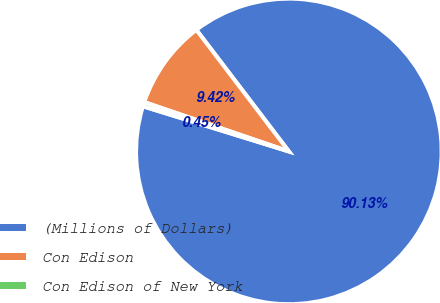<chart> <loc_0><loc_0><loc_500><loc_500><pie_chart><fcel>(Millions of Dollars)<fcel>Con Edison<fcel>Con Edison of New York<nl><fcel>90.13%<fcel>9.42%<fcel>0.45%<nl></chart> 